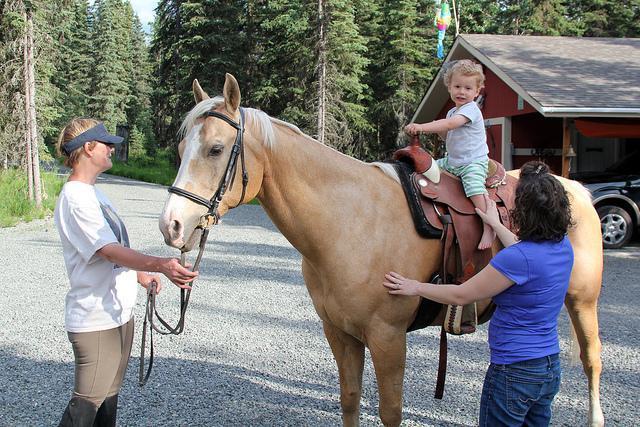How many people are on top of the horse?
Give a very brief answer. 1. How many people are in the photo?
Give a very brief answer. 3. 